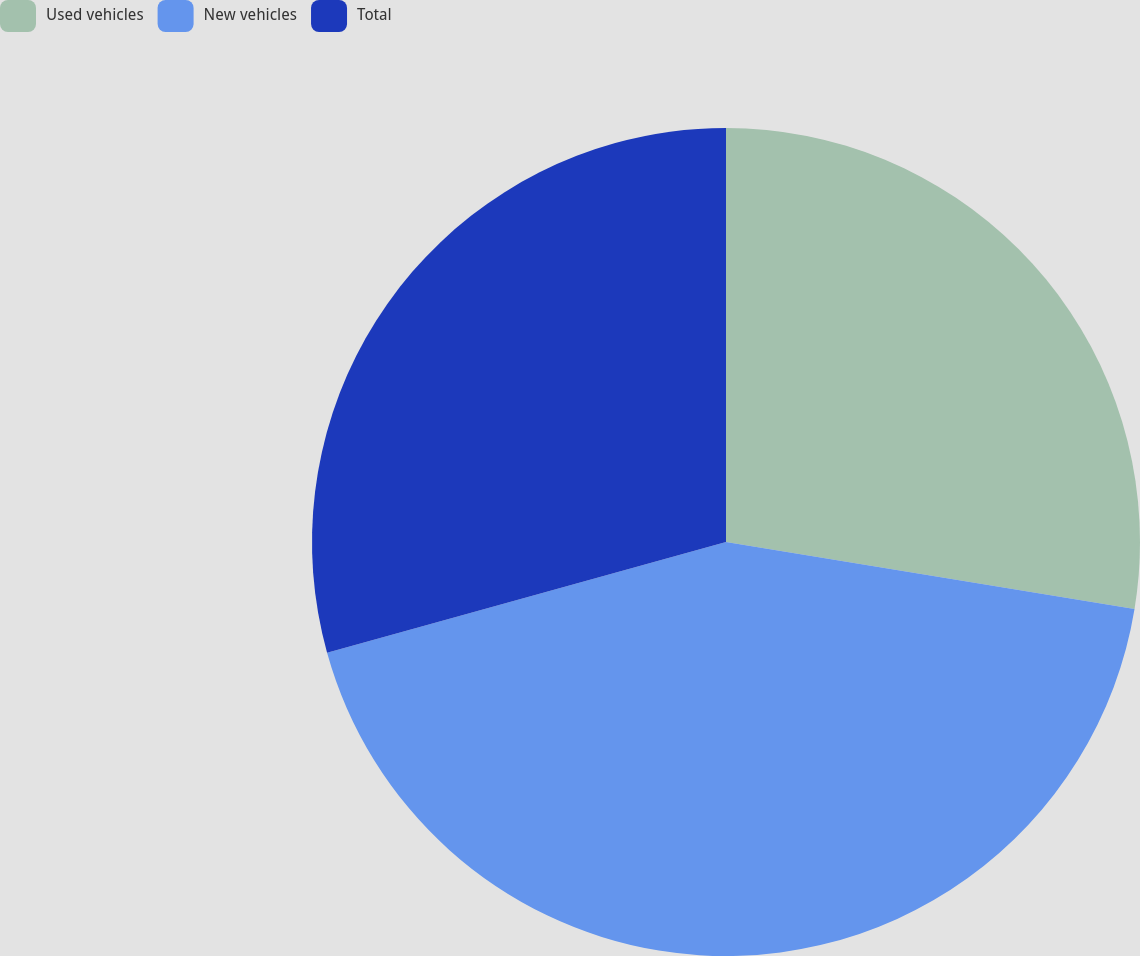Convert chart. <chart><loc_0><loc_0><loc_500><loc_500><pie_chart><fcel>Used vehicles<fcel>New vehicles<fcel>Total<nl><fcel>27.59%<fcel>43.1%<fcel>29.31%<nl></chart> 